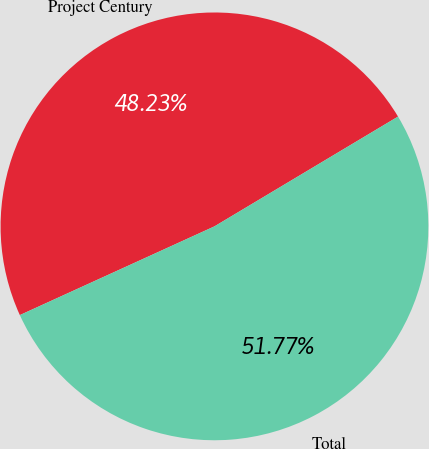Convert chart. <chart><loc_0><loc_0><loc_500><loc_500><pie_chart><fcel>Project Century<fcel>Total<nl><fcel>48.23%<fcel>51.77%<nl></chart> 